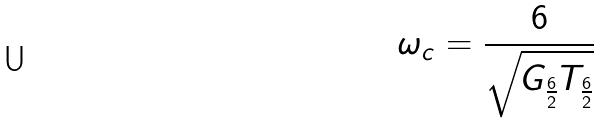Convert formula to latex. <formula><loc_0><loc_0><loc_500><loc_500>\omega _ { c } = \frac { 6 } { \sqrt { G _ { \frac { 6 } { 2 } } T _ { \frac { 6 } { 2 } } } }</formula> 